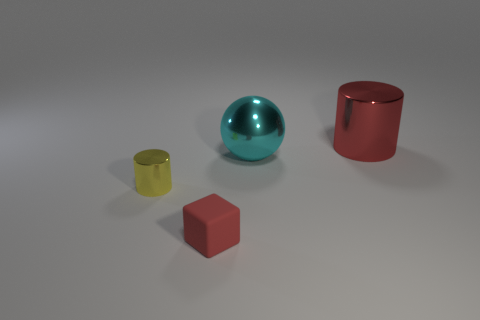What number of red things are the same size as the shiny sphere?
Keep it short and to the point. 1. What is the shape of the big metallic thing that is the same color as the rubber cube?
Ensure brevity in your answer.  Cylinder. Is the color of the cylinder that is in front of the cyan sphere the same as the shiny cylinder on the right side of the red rubber object?
Ensure brevity in your answer.  No. How many large cyan spheres are on the right side of the tiny metal cylinder?
Your answer should be very brief. 1. What is the size of the cylinder that is the same color as the tiny rubber cube?
Your response must be concise. Large. Is there another small rubber object of the same shape as the yellow thing?
Provide a succinct answer. No. There is a shiny cylinder that is the same size as the cyan sphere; what is its color?
Make the answer very short. Red. Are there fewer small metal objects that are to the right of the large cyan metal thing than red matte objects behind the yellow cylinder?
Offer a terse response. No. Do the metal cylinder that is in front of the metal sphere and the red metal cylinder have the same size?
Give a very brief answer. No. The red thing that is in front of the yellow cylinder has what shape?
Offer a terse response. Cube. 